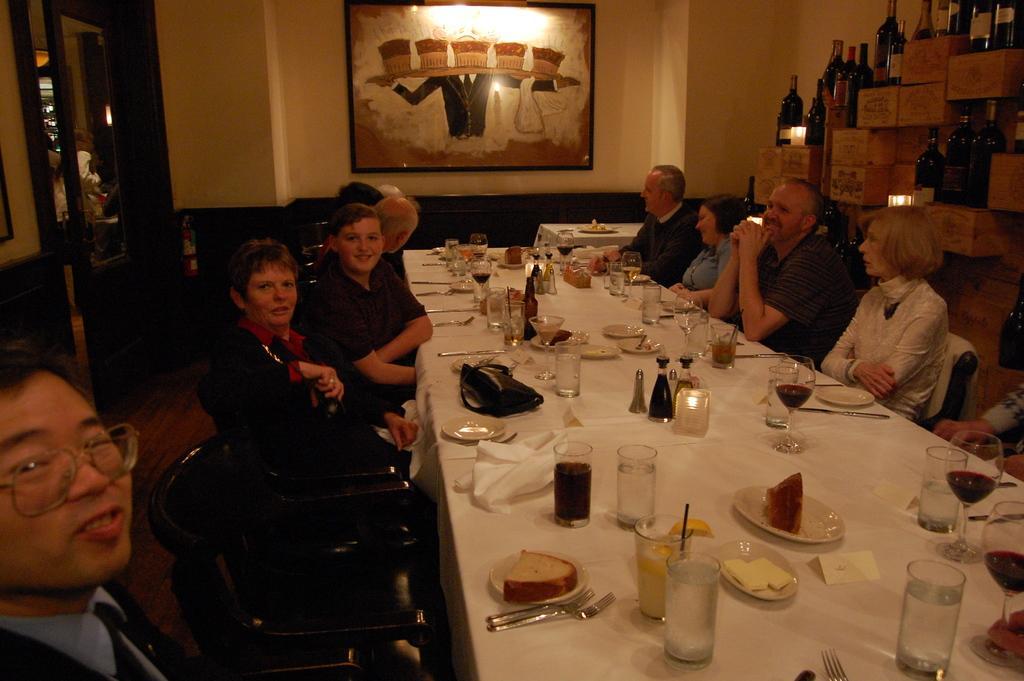Can you describe this image briefly? This picture is clicked inside the room. Here, we see many people sitting on either side of the table. On the table, we see water glass, cool drink glass, black bag, plate, bread, fork, spoon, knife and many plates are placed on it. Behind this people, we see many cotton boxes on which many wine or alcohol bottles are placed. On background, we see white wall on which a photo frame is placed. On the left corner, we see a mirror. 